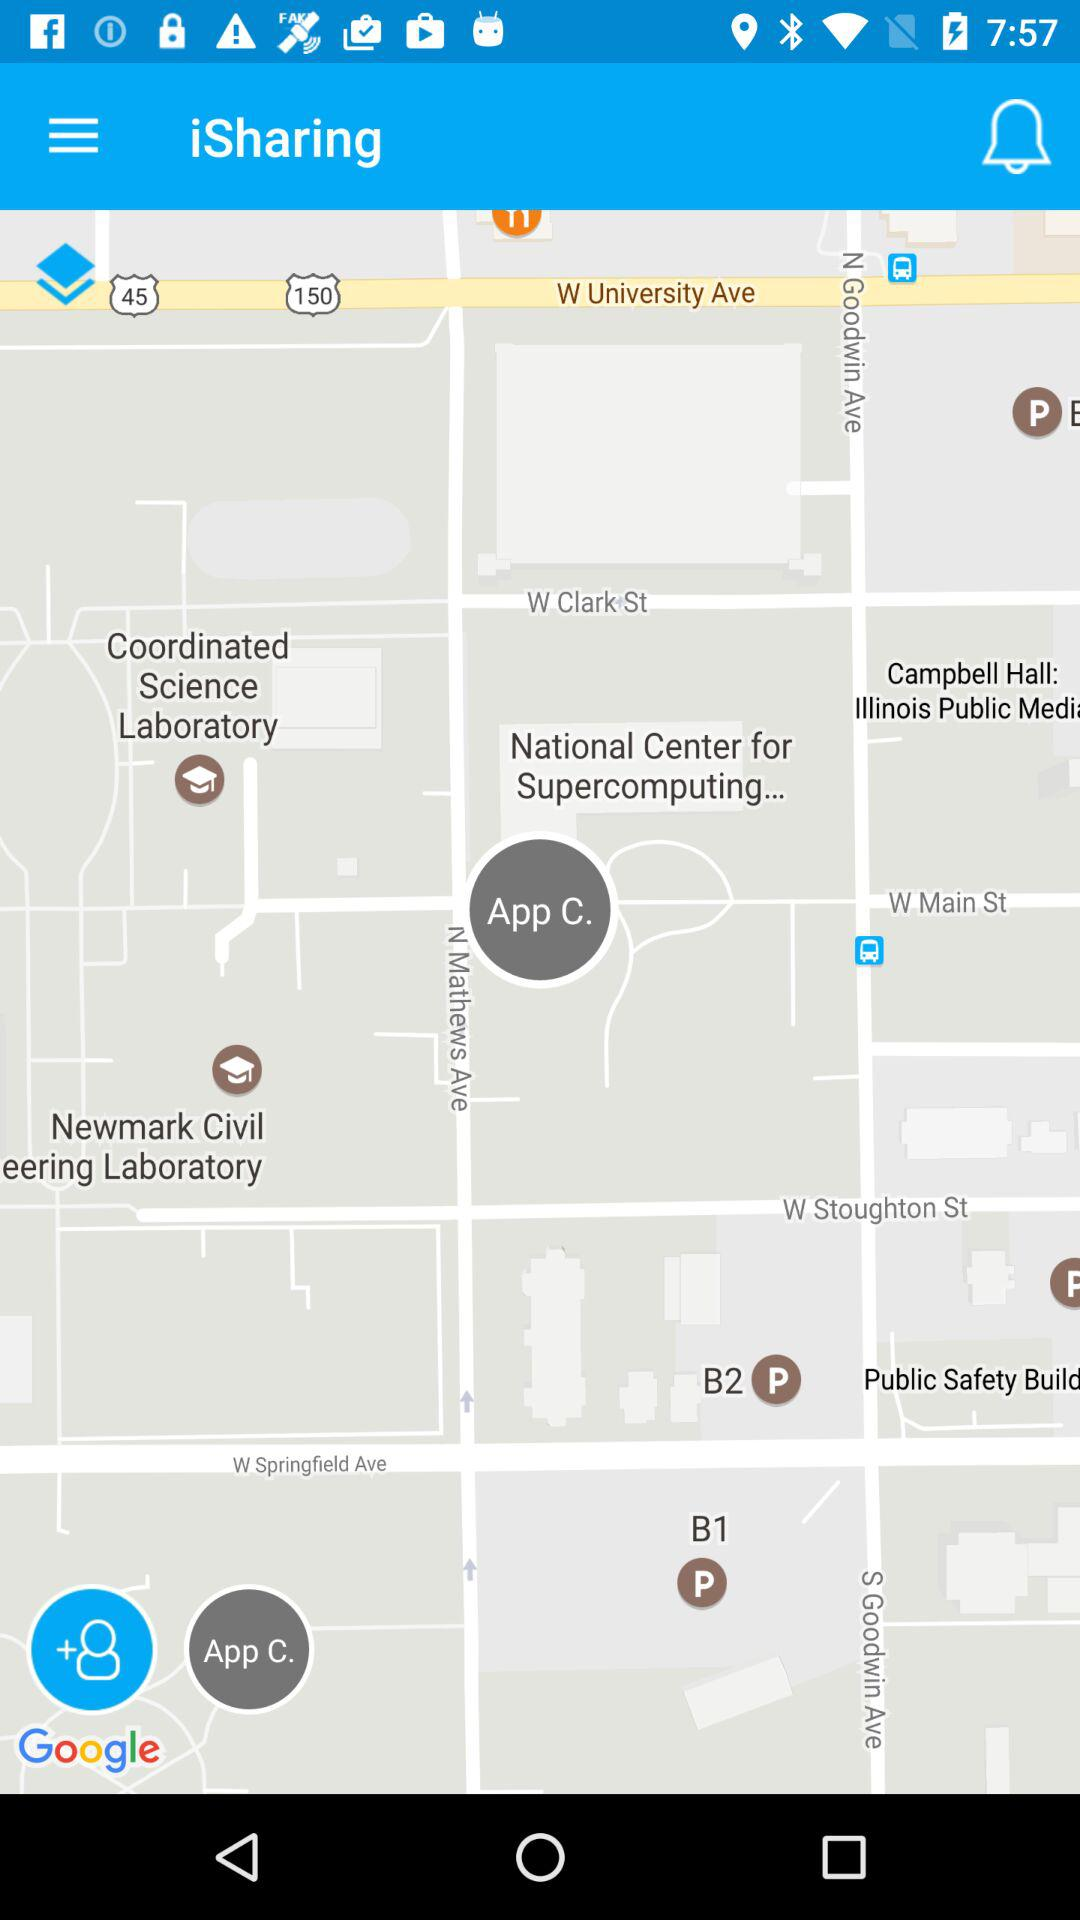What is the application name? The application name is "iSharing". 